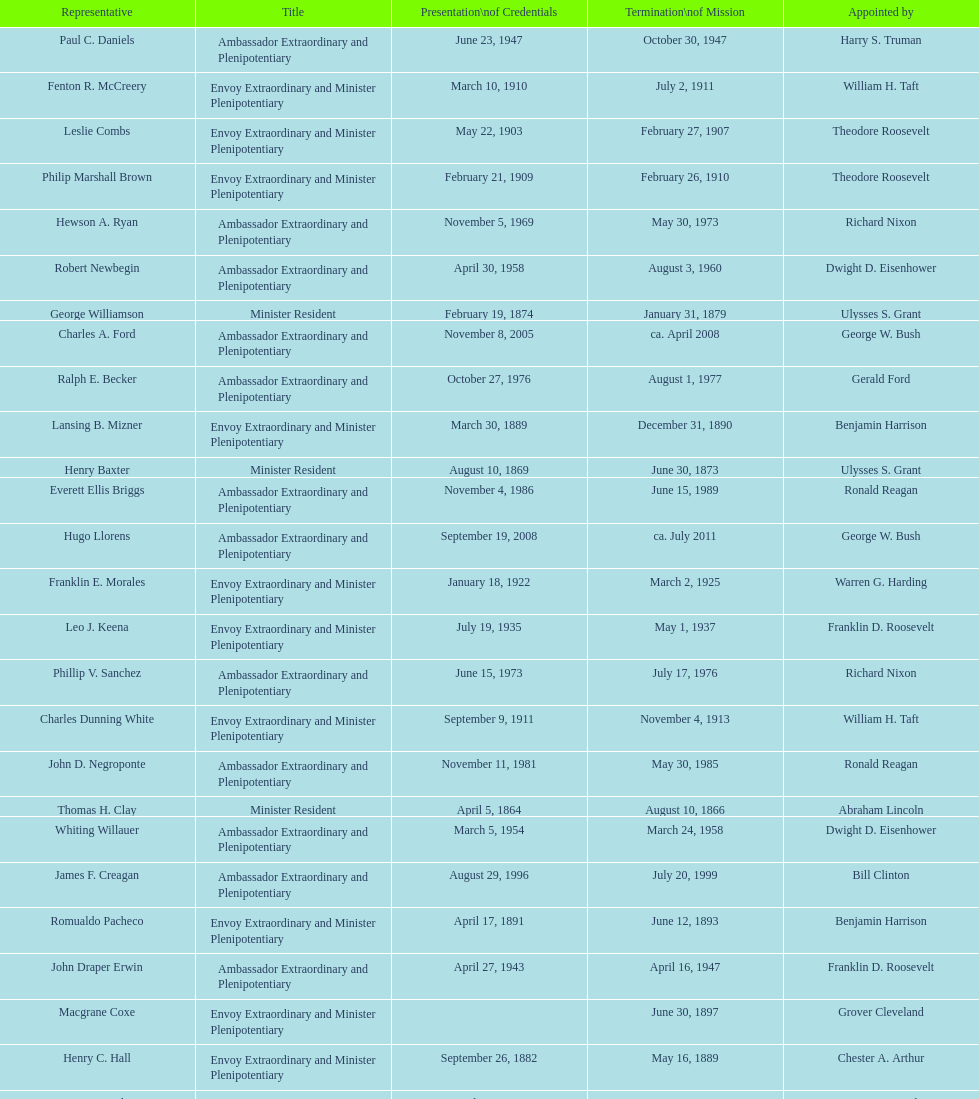Which envoy was the first appointed by woodrow wilson? John Ewing. 